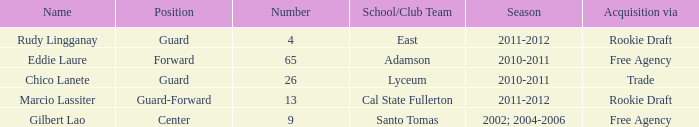What number has an acquisition via the Rookie Draft, and is part of a School/club team at Cal State Fullerton? 13.0. 